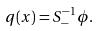<formula> <loc_0><loc_0><loc_500><loc_500>q ( x ) = S _ { - } ^ { - 1 } \phi .</formula> 